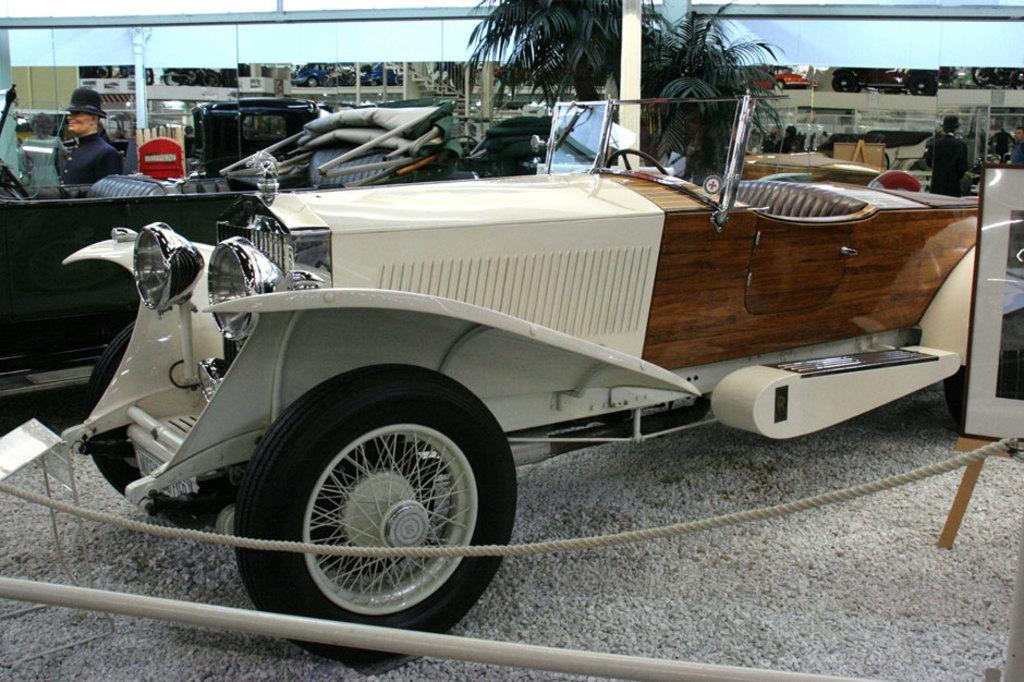How would you summarize this image in a sentence or two? In the image we can see there are vehicles and we can see there are even people standing and one is sitting. Here we can see the rope, board, trees and the pole. 